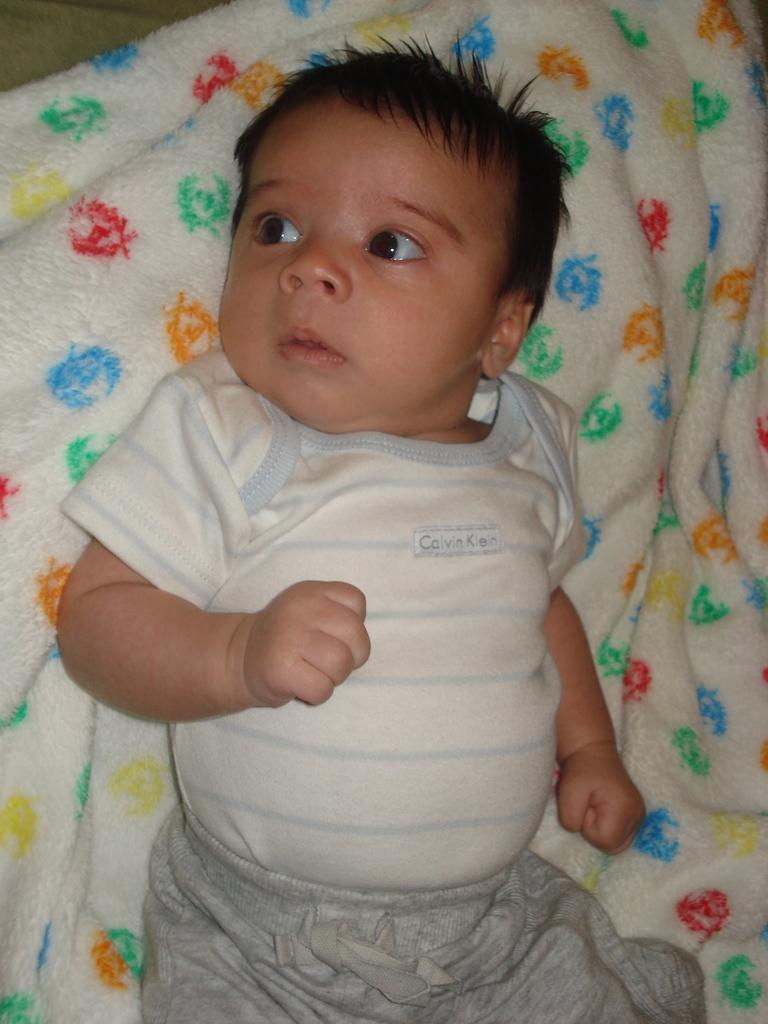What is the main subject of the image? The main subject of the image is a kid. What is the kid doing in the image? The kid is lying on a blanket. How does the zephyr affect the kid's eye in the image? There is no mention of a zephyr or any wind in the image, and the kid's eye is not visible. 